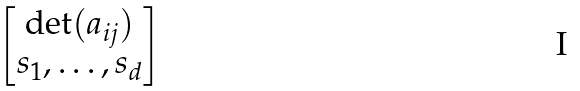<formula> <loc_0><loc_0><loc_500><loc_500>\begin{bmatrix} \det ( a _ { i j } ) \\ s _ { 1 } , \dots , s _ { d } \end{bmatrix}</formula> 